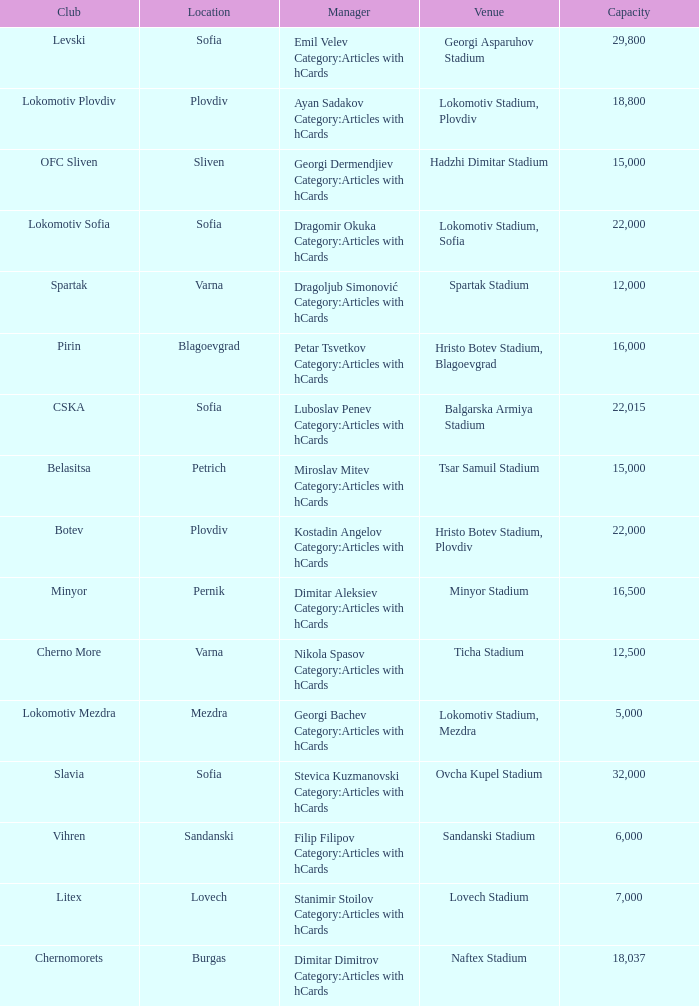What is the highest capacity for the venue of the club, vihren? 6000.0. 